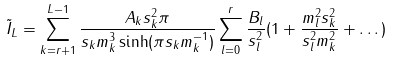<formula> <loc_0><loc_0><loc_500><loc_500>\tilde { I } _ { L } = \sum _ { k = r + 1 } ^ { L - 1 } \frac { A _ { k } s _ { k } ^ { 2 } \pi } { s _ { k } m _ { k } ^ { 3 } \sinh ( \pi s _ { k } m _ { k } ^ { - 1 } ) } \sum _ { l = 0 } ^ { r } \frac { B _ { l } } { s _ { l } ^ { 2 } } ( 1 + \frac { m _ { l } ^ { 2 } s _ { k } ^ { 2 } } { s _ { l } ^ { 2 } m _ { k } ^ { 2 } } + \dots )</formula> 